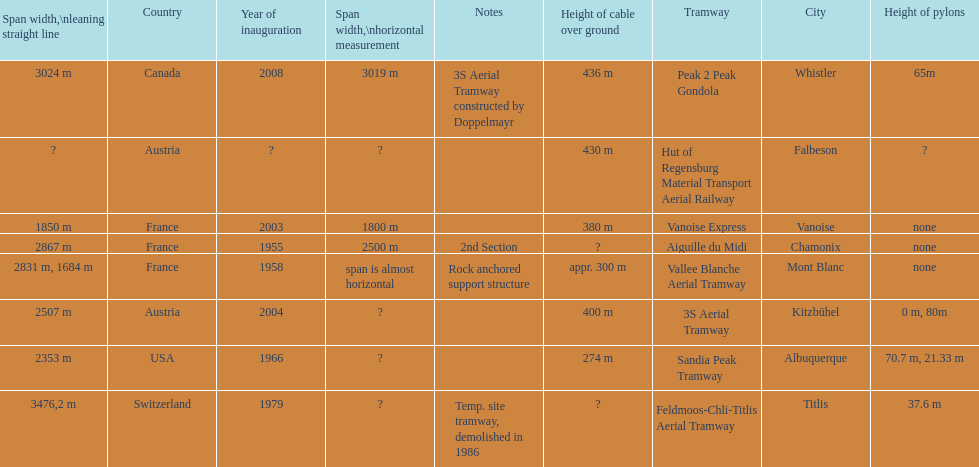How much greater is the height of cable over ground measurement for the peak 2 peak gondola when compared with that of the vanoise express? 56 m. Parse the full table. {'header': ['Span\xa0width,\\nleaning straight line', 'Country', 'Year of inauguration', 'Span width,\\nhorizontal measurement', 'Notes', 'Height of cable over ground', 'Tramway', 'City', 'Height of pylons'], 'rows': [['3024 m', 'Canada', '2008', '3019 m', '3S Aerial Tramway constructed by Doppelmayr', '436 m', 'Peak 2 Peak Gondola', 'Whistler', '65m'], ['?', 'Austria', '?', '?', '', '430 m', 'Hut of Regensburg Material Transport Aerial Railway', 'Falbeson', '?'], ['1850 m', 'France', '2003', '1800 m', '', '380 m', 'Vanoise Express', 'Vanoise', 'none'], ['2867 m', 'France', '1955', '2500 m', '2nd Section', '?', 'Aiguille du Midi', 'Chamonix', 'none'], ['2831 m, 1684 m', 'France', '1958', 'span is almost horizontal', 'Rock anchored support structure', 'appr. 300 m', 'Vallee Blanche Aerial Tramway', 'Mont Blanc', 'none'], ['2507 m', 'Austria', '2004', '?', '', '400 m', '3S Aerial Tramway', 'Kitzbühel', '0 m, 80m'], ['2353 m', 'USA', '1966', '?', '', '274 m', 'Sandia Peak Tramway', 'Albuquerque', '70.7 m, 21.33 m'], ['3476,2 m', 'Switzerland', '1979', '?', 'Temp. site tramway, demolished in 1986', '?', 'Feldmoos-Chli-Titlis Aerial Tramway', 'Titlis', '37.6 m']]} 